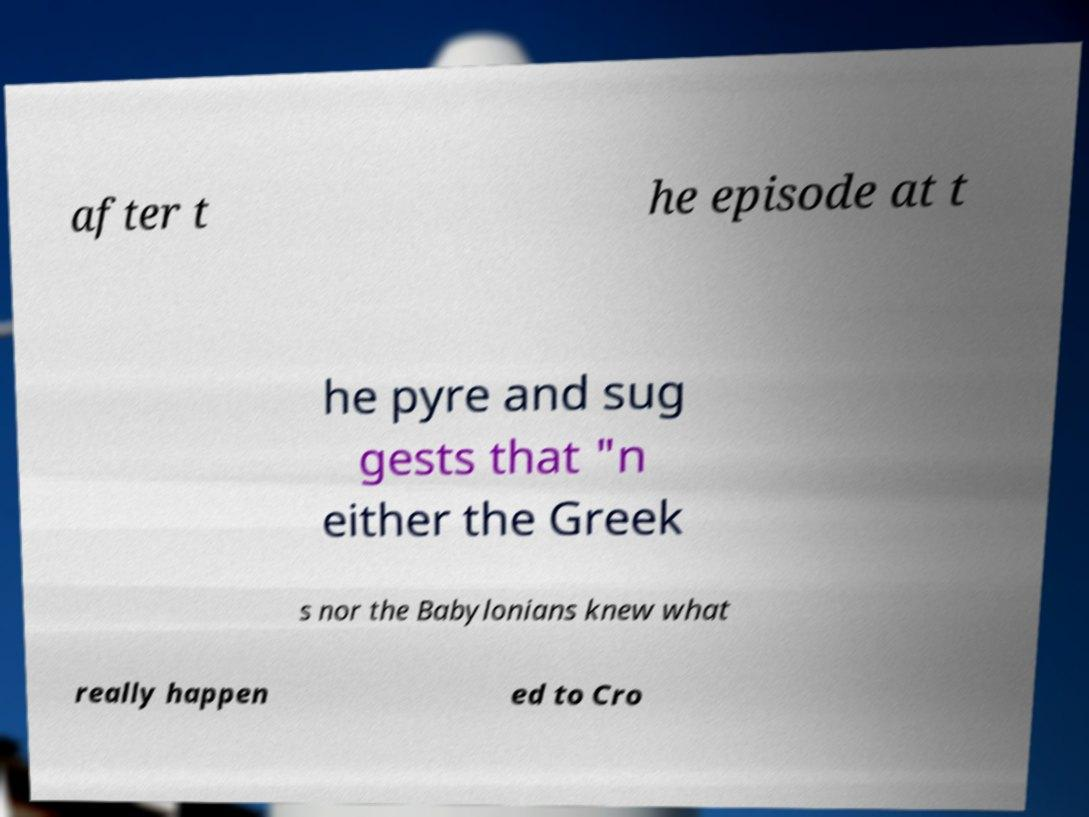For documentation purposes, I need the text within this image transcribed. Could you provide that? after t he episode at t he pyre and sug gests that "n either the Greek s nor the Babylonians knew what really happen ed to Cro 